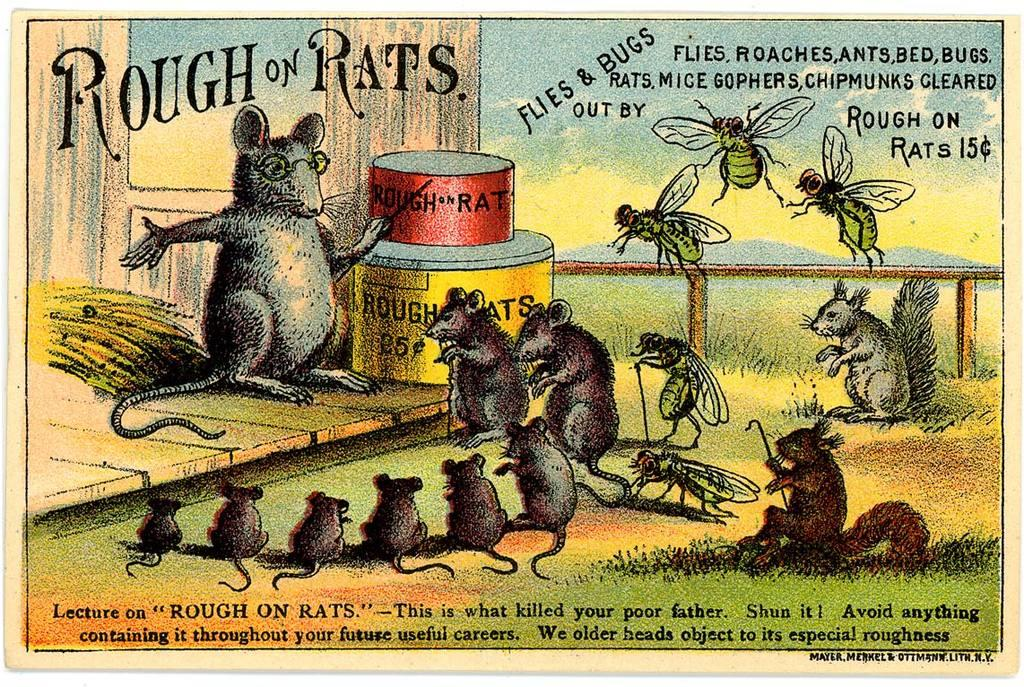What type of visual is depicted in the image? The image is a poster. What animals are featured in the poster? There are rats, mice, and a fly in the image. Where is the text located on the poster? The text is written at the top and bottom of the image. What route do the rabbits take in the image? There are no rabbits present in the image, so there is no route to describe. 